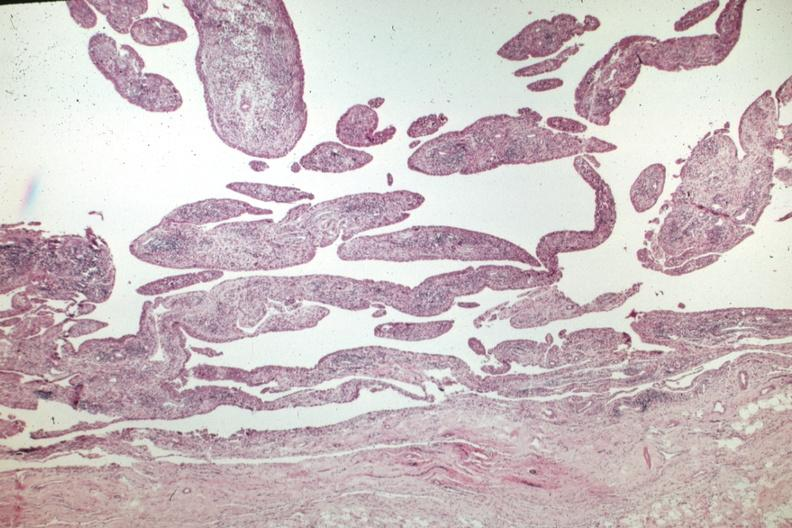s joints present?
Answer the question using a single word or phrase. Yes 